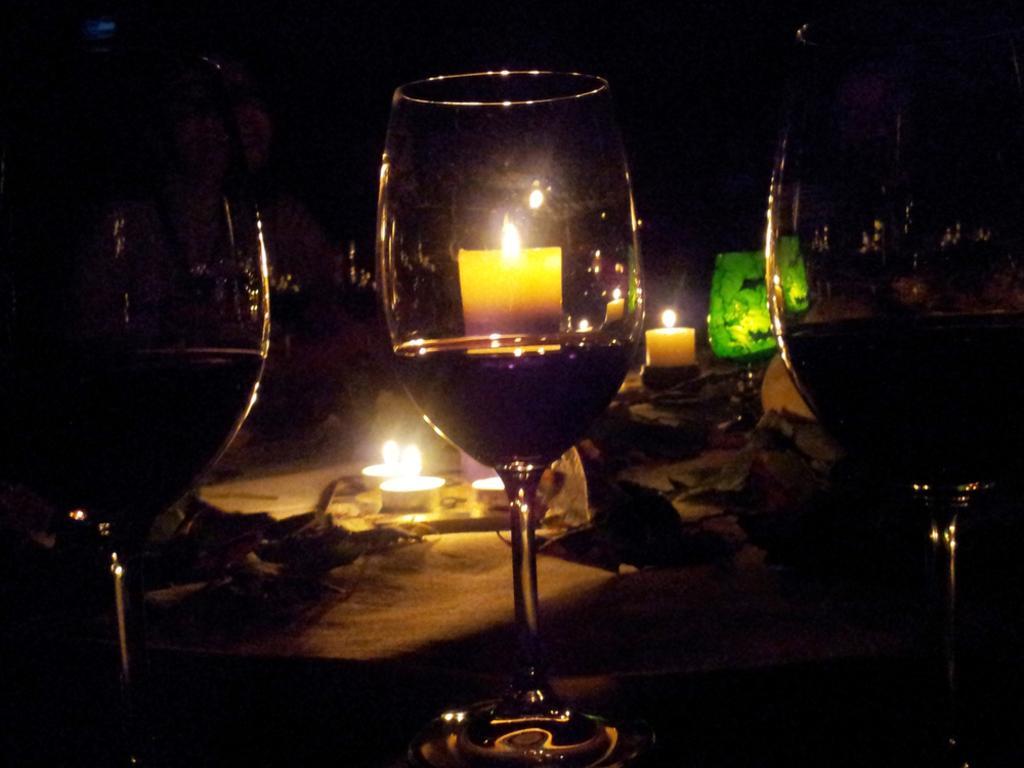In one or two sentences, can you explain what this image depicts? In this image we can see some glasses, candles and some objects placed on the surface. 